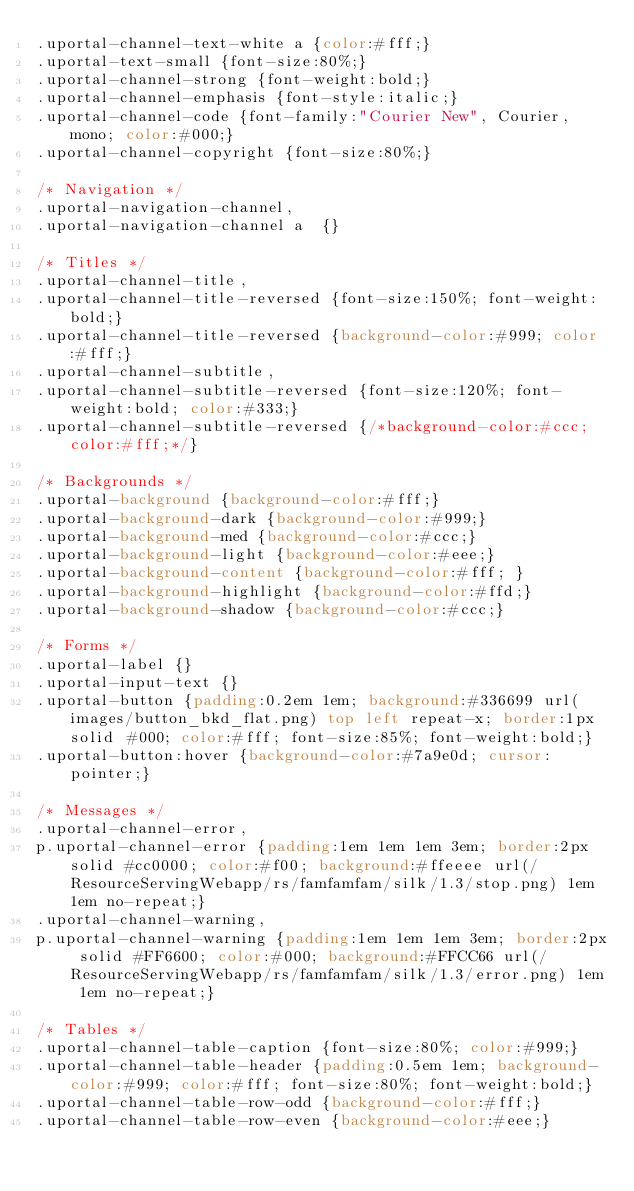<code> <loc_0><loc_0><loc_500><loc_500><_CSS_>.uportal-channel-text-white a {color:#fff;}
.uportal-text-small {font-size:80%;}
.uportal-channel-strong {font-weight:bold;}
.uportal-channel-emphasis {font-style:italic;}
.uportal-channel-code {font-family:"Courier New", Courier, mono; color:#000;}
.uportal-channel-copyright {font-size:80%;}

/* Navigation */
.uportal-navigation-channel,
.uportal-navigation-channel a  {}

/* Titles */
.uportal-channel-title,
.uportal-channel-title-reversed {font-size:150%; font-weight:bold;}
.uportal-channel-title-reversed {background-color:#999; color:#fff;}
.uportal-channel-subtitle,
.uportal-channel-subtitle-reversed {font-size:120%; font-weight:bold; color:#333;}
.uportal-channel-subtitle-reversed {/*background-color:#ccc; color:#fff;*/}

/* Backgrounds */
.uportal-background {background-color:#fff;}
.uportal-background-dark {background-color:#999;}
.uportal-background-med {background-color:#ccc;}
.uportal-background-light {background-color:#eee;}
.uportal-background-content {background-color:#fff; }
.uportal-background-highlight {background-color:#ffd;}
.uportal-background-shadow {background-color:#ccc;}

/* Forms */
.uportal-label {}
.uportal-input-text {}
.uportal-button {padding:0.2em 1em; background:#336699 url(images/button_bkd_flat.png) top left repeat-x; border:1px solid #000; color:#fff; font-size:85%; font-weight:bold;}
.uportal-button:hover {background-color:#7a9e0d; cursor:pointer;}

/* Messages */
.uportal-channel-error, 
p.uportal-channel-error {padding:1em 1em 1em 3em; border:2px solid #cc0000; color:#f00; background:#ffeeee url(/ResourceServingWebapp/rs/famfamfam/silk/1.3/stop.png) 1em 1em no-repeat;}
.uportal-channel-warning,
p.uportal-channel-warning {padding:1em 1em 1em 3em; border:2px solid #FF6600; color:#000; background:#FFCC66 url(/ResourceServingWebapp/rs/famfamfam/silk/1.3/error.png) 1em 1em no-repeat;}

/* Tables */
.uportal-channel-table-caption {font-size:80%; color:#999;}
.uportal-channel-table-header {padding:0.5em 1em; background-color:#999; color:#fff; font-size:80%; font-weight:bold;}
.uportal-channel-table-row-odd {background-color:#fff;}
.uportal-channel-table-row-even {background-color:#eee;}

</code> 